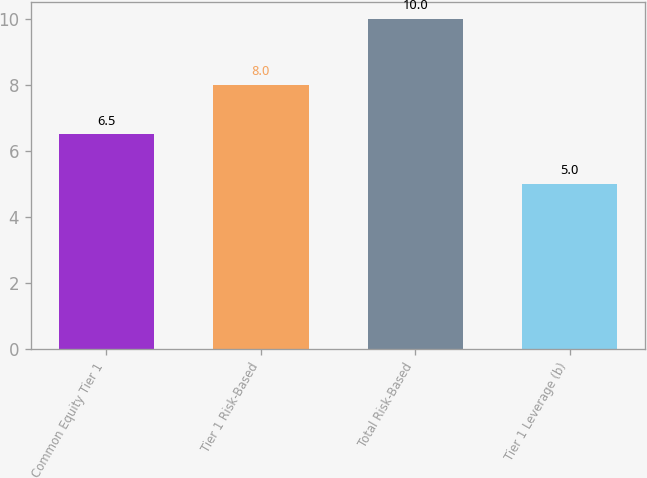<chart> <loc_0><loc_0><loc_500><loc_500><bar_chart><fcel>Common Equity Tier 1<fcel>Tier 1 Risk-Based<fcel>Total Risk-Based<fcel>Tier 1 Leverage (b)<nl><fcel>6.5<fcel>8<fcel>10<fcel>5<nl></chart> 